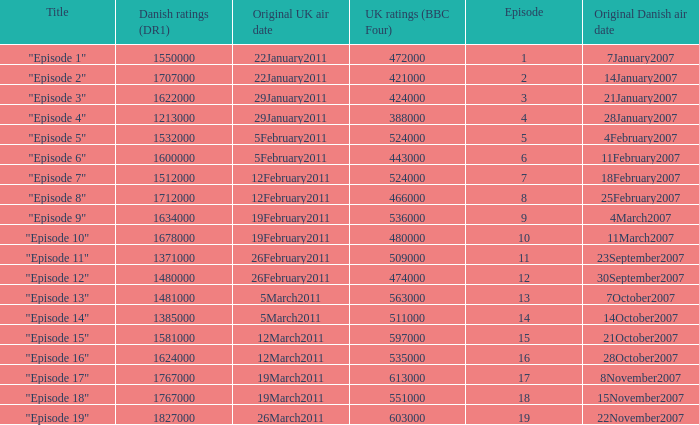What were the UK ratings (BBC Four) for "Episode 17"?  613000.0. 